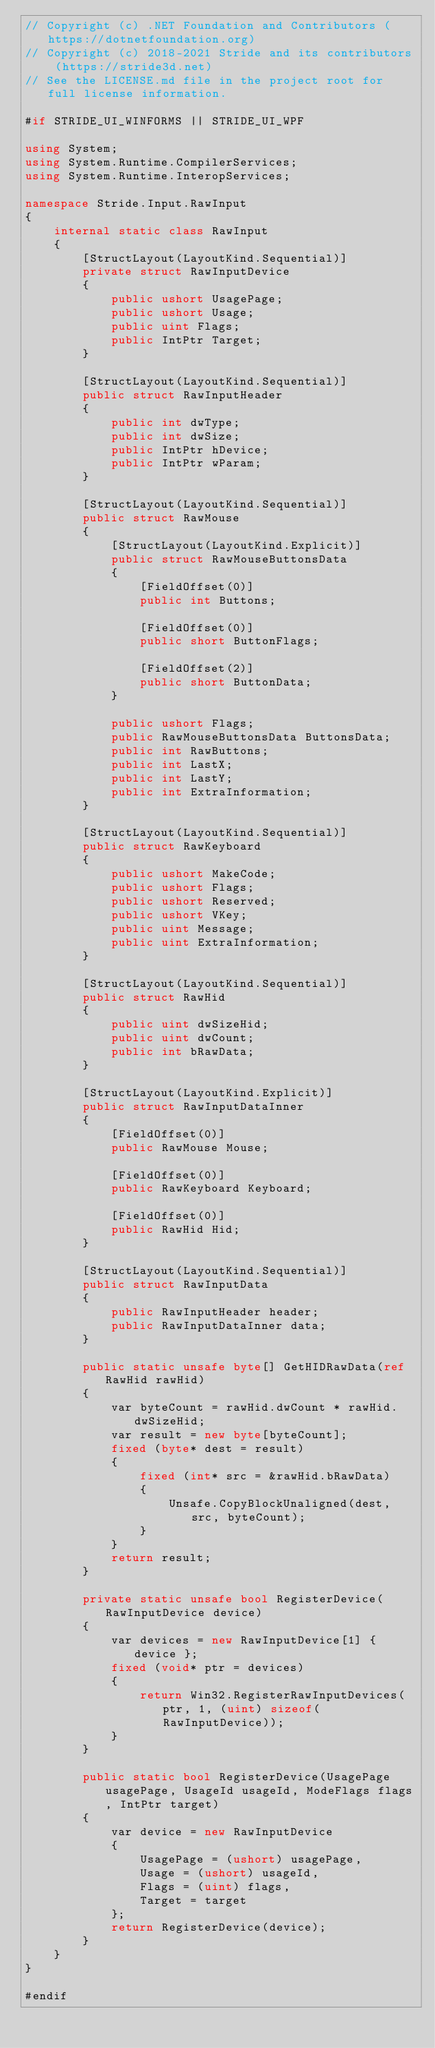Convert code to text. <code><loc_0><loc_0><loc_500><loc_500><_C#_>// Copyright (c) .NET Foundation and Contributors (https://dotnetfoundation.org)
// Copyright (c) 2018-2021 Stride and its contributors (https://stride3d.net)
// See the LICENSE.md file in the project root for full license information.

#if STRIDE_UI_WINFORMS || STRIDE_UI_WPF

using System;
using System.Runtime.CompilerServices;
using System.Runtime.InteropServices;

namespace Stride.Input.RawInput
{
    internal static class RawInput
    {
        [StructLayout(LayoutKind.Sequential)]
        private struct RawInputDevice
        {
            public ushort UsagePage;
            public ushort Usage;
            public uint Flags;
            public IntPtr Target;
        }

        [StructLayout(LayoutKind.Sequential)]
        public struct RawInputHeader
        {
            public int dwType;
            public int dwSize;
            public IntPtr hDevice;
            public IntPtr wParam;
        }

        [StructLayout(LayoutKind.Sequential)]
        public struct RawMouse
        {
            [StructLayout(LayoutKind.Explicit)]
            public struct RawMouseButtonsData
            {
                [FieldOffset(0)]
                public int Buttons;

                [FieldOffset(0)]
                public short ButtonFlags;

                [FieldOffset(2)]
                public short ButtonData;
            }

            public ushort Flags;
            public RawMouseButtonsData ButtonsData;
            public int RawButtons;
            public int LastX;
            public int LastY;
            public int ExtraInformation;
        }

        [StructLayout(LayoutKind.Sequential)]
        public struct RawKeyboard
        {
            public ushort MakeCode;
            public ushort Flags;
            public ushort Reserved;
            public ushort VKey;
            public uint Message;
            public uint ExtraInformation;
        }

        [StructLayout(LayoutKind.Sequential)]
        public struct RawHid
        {
            public uint dwSizeHid;
            public uint dwCount;
            public int bRawData;
        }

        [StructLayout(LayoutKind.Explicit)]
        public struct RawInputDataInner
        {
            [FieldOffset(0)]
            public RawMouse Mouse;

            [FieldOffset(0)]
            public RawKeyboard Keyboard;

            [FieldOffset(0)]
            public RawHid Hid;
        }

        [StructLayout(LayoutKind.Sequential)]
        public struct RawInputData
        {
            public RawInputHeader header;
            public RawInputDataInner data;
        }

        public static unsafe byte[] GetHIDRawData(ref RawHid rawHid)
        {
            var byteCount = rawHid.dwCount * rawHid.dwSizeHid;
            var result = new byte[byteCount];
            fixed (byte* dest = result)
            {
                fixed (int* src = &rawHid.bRawData)
                {
                    Unsafe.CopyBlockUnaligned(dest, src, byteCount);
                }
            }
            return result;
        }

        private static unsafe bool RegisterDevice(RawInputDevice device)
        {
            var devices = new RawInputDevice[1] { device };
            fixed (void* ptr = devices)
            {
                return Win32.RegisterRawInputDevices(ptr, 1, (uint) sizeof(RawInputDevice));
            }
        }

        public static bool RegisterDevice(UsagePage usagePage, UsageId usageId, ModeFlags flags, IntPtr target)
        {
            var device = new RawInputDevice
            {
                UsagePage = (ushort) usagePage,
                Usage = (ushort) usageId,
                Flags = (uint) flags,
                Target = target
            };
            return RegisterDevice(device);
        }
    }
}

#endif
</code> 